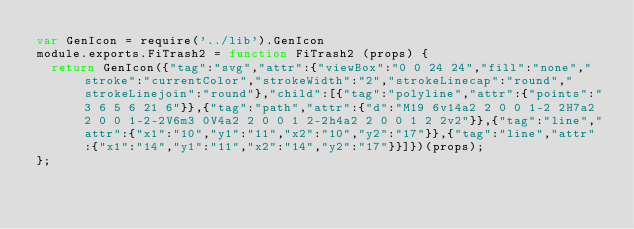Convert code to text. <code><loc_0><loc_0><loc_500><loc_500><_JavaScript_>var GenIcon = require('../lib').GenIcon
module.exports.FiTrash2 = function FiTrash2 (props) {
  return GenIcon({"tag":"svg","attr":{"viewBox":"0 0 24 24","fill":"none","stroke":"currentColor","strokeWidth":"2","strokeLinecap":"round","strokeLinejoin":"round"},"child":[{"tag":"polyline","attr":{"points":"3 6 5 6 21 6"}},{"tag":"path","attr":{"d":"M19 6v14a2 2 0 0 1-2 2H7a2 2 0 0 1-2-2V6m3 0V4a2 2 0 0 1 2-2h4a2 2 0 0 1 2 2v2"}},{"tag":"line","attr":{"x1":"10","y1":"11","x2":"10","y2":"17"}},{"tag":"line","attr":{"x1":"14","y1":"11","x2":"14","y2":"17"}}]})(props);
};
</code> 